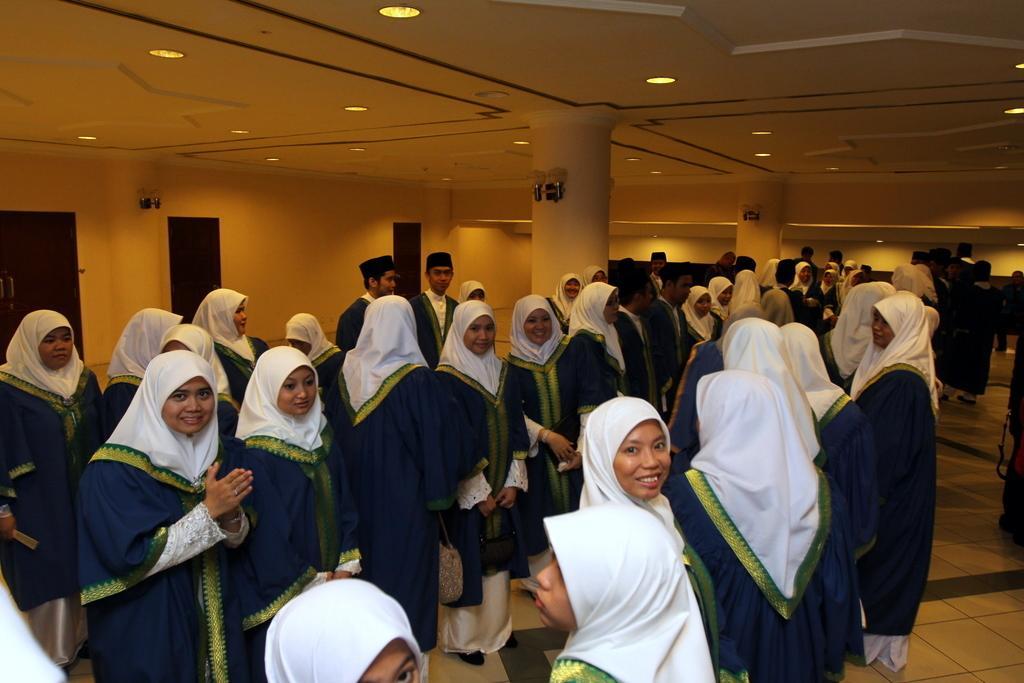In one or two sentences, can you explain what this image depicts? In this image, we can see people and some are wearing caps. At the top, there are lights and we can see a roof and some pillars. At the bottom, there is a floor. 